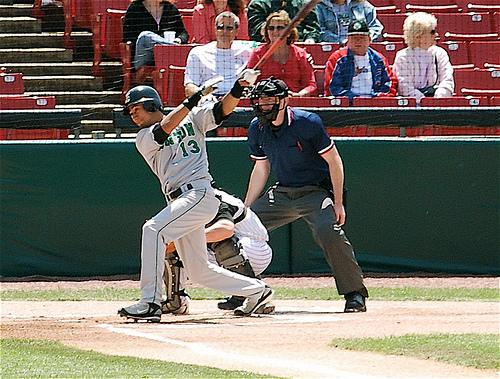What kind of shoes is the baseball player wearing?
Write a very short answer. Cleats. What sport is being played?
Write a very short answer. Baseball. How many people are visible in the stands?
Give a very brief answer. 8. 